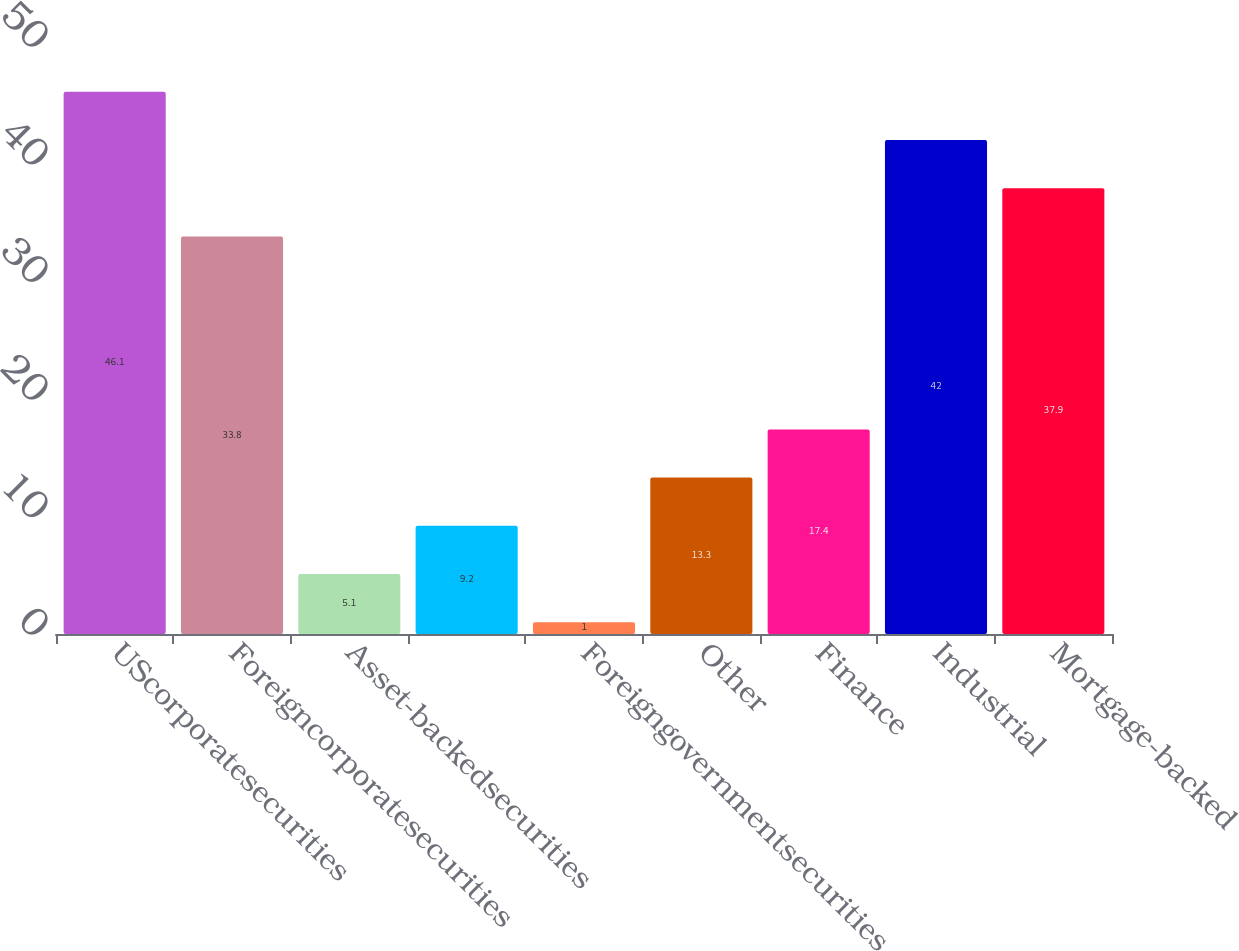Convert chart. <chart><loc_0><loc_0><loc_500><loc_500><bar_chart><fcel>UScorporatesecurities<fcel>Foreigncorporatesecurities<fcel>Asset-backedsecurities<fcel>Unnamed: 3<fcel>Foreigngovernmentsecurities<fcel>Other<fcel>Finance<fcel>Industrial<fcel>Mortgage-backed<nl><fcel>46.1<fcel>33.8<fcel>5.1<fcel>9.2<fcel>1<fcel>13.3<fcel>17.4<fcel>42<fcel>37.9<nl></chart> 